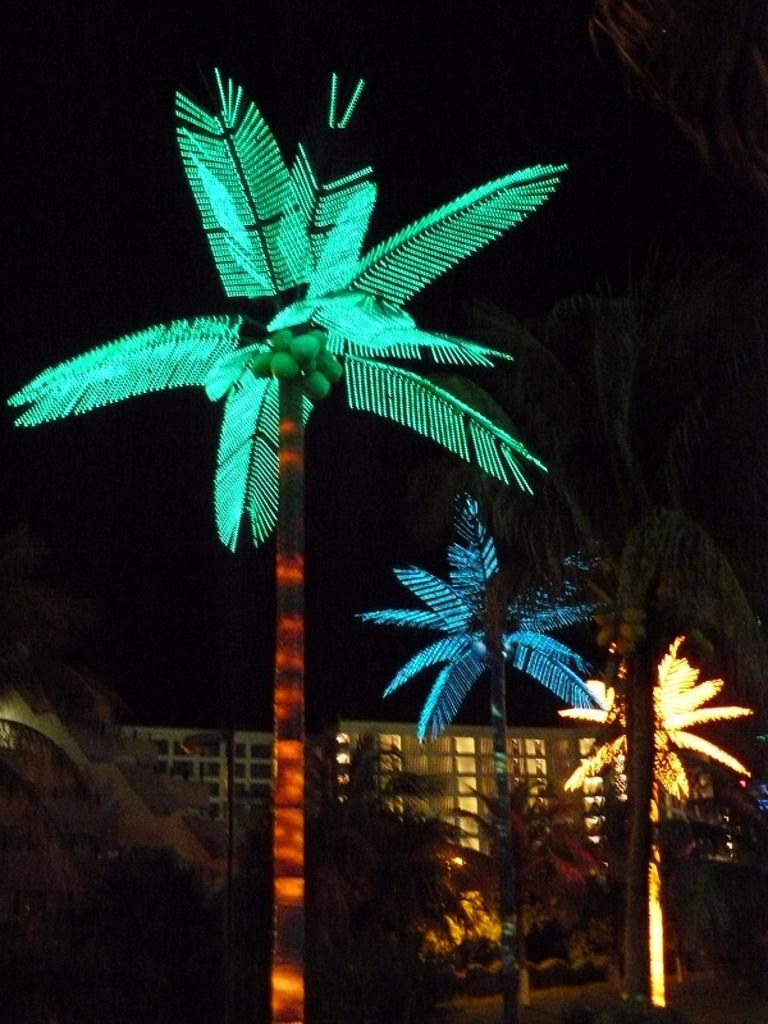What type of vegetation is visible in the front of the image? There are trees in the front of the image. What type of structure can be seen in the background of the image? There is a building in the background of the image. How would you describe the lighting in the image? The background of the image is dark. What type of neck accessory is the manager wearing in the image? There is no manager or neck accessory present in the image. How many arrows are in the quiver in the image? There is no quiver or arrows present in the image. 